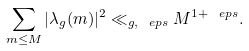<formula> <loc_0><loc_0><loc_500><loc_500>\sum _ { m \leq M } | \lambda _ { g } ( m ) | ^ { 2 } \ll _ { g , \ e p s } M ^ { 1 + \ e p s } .</formula> 